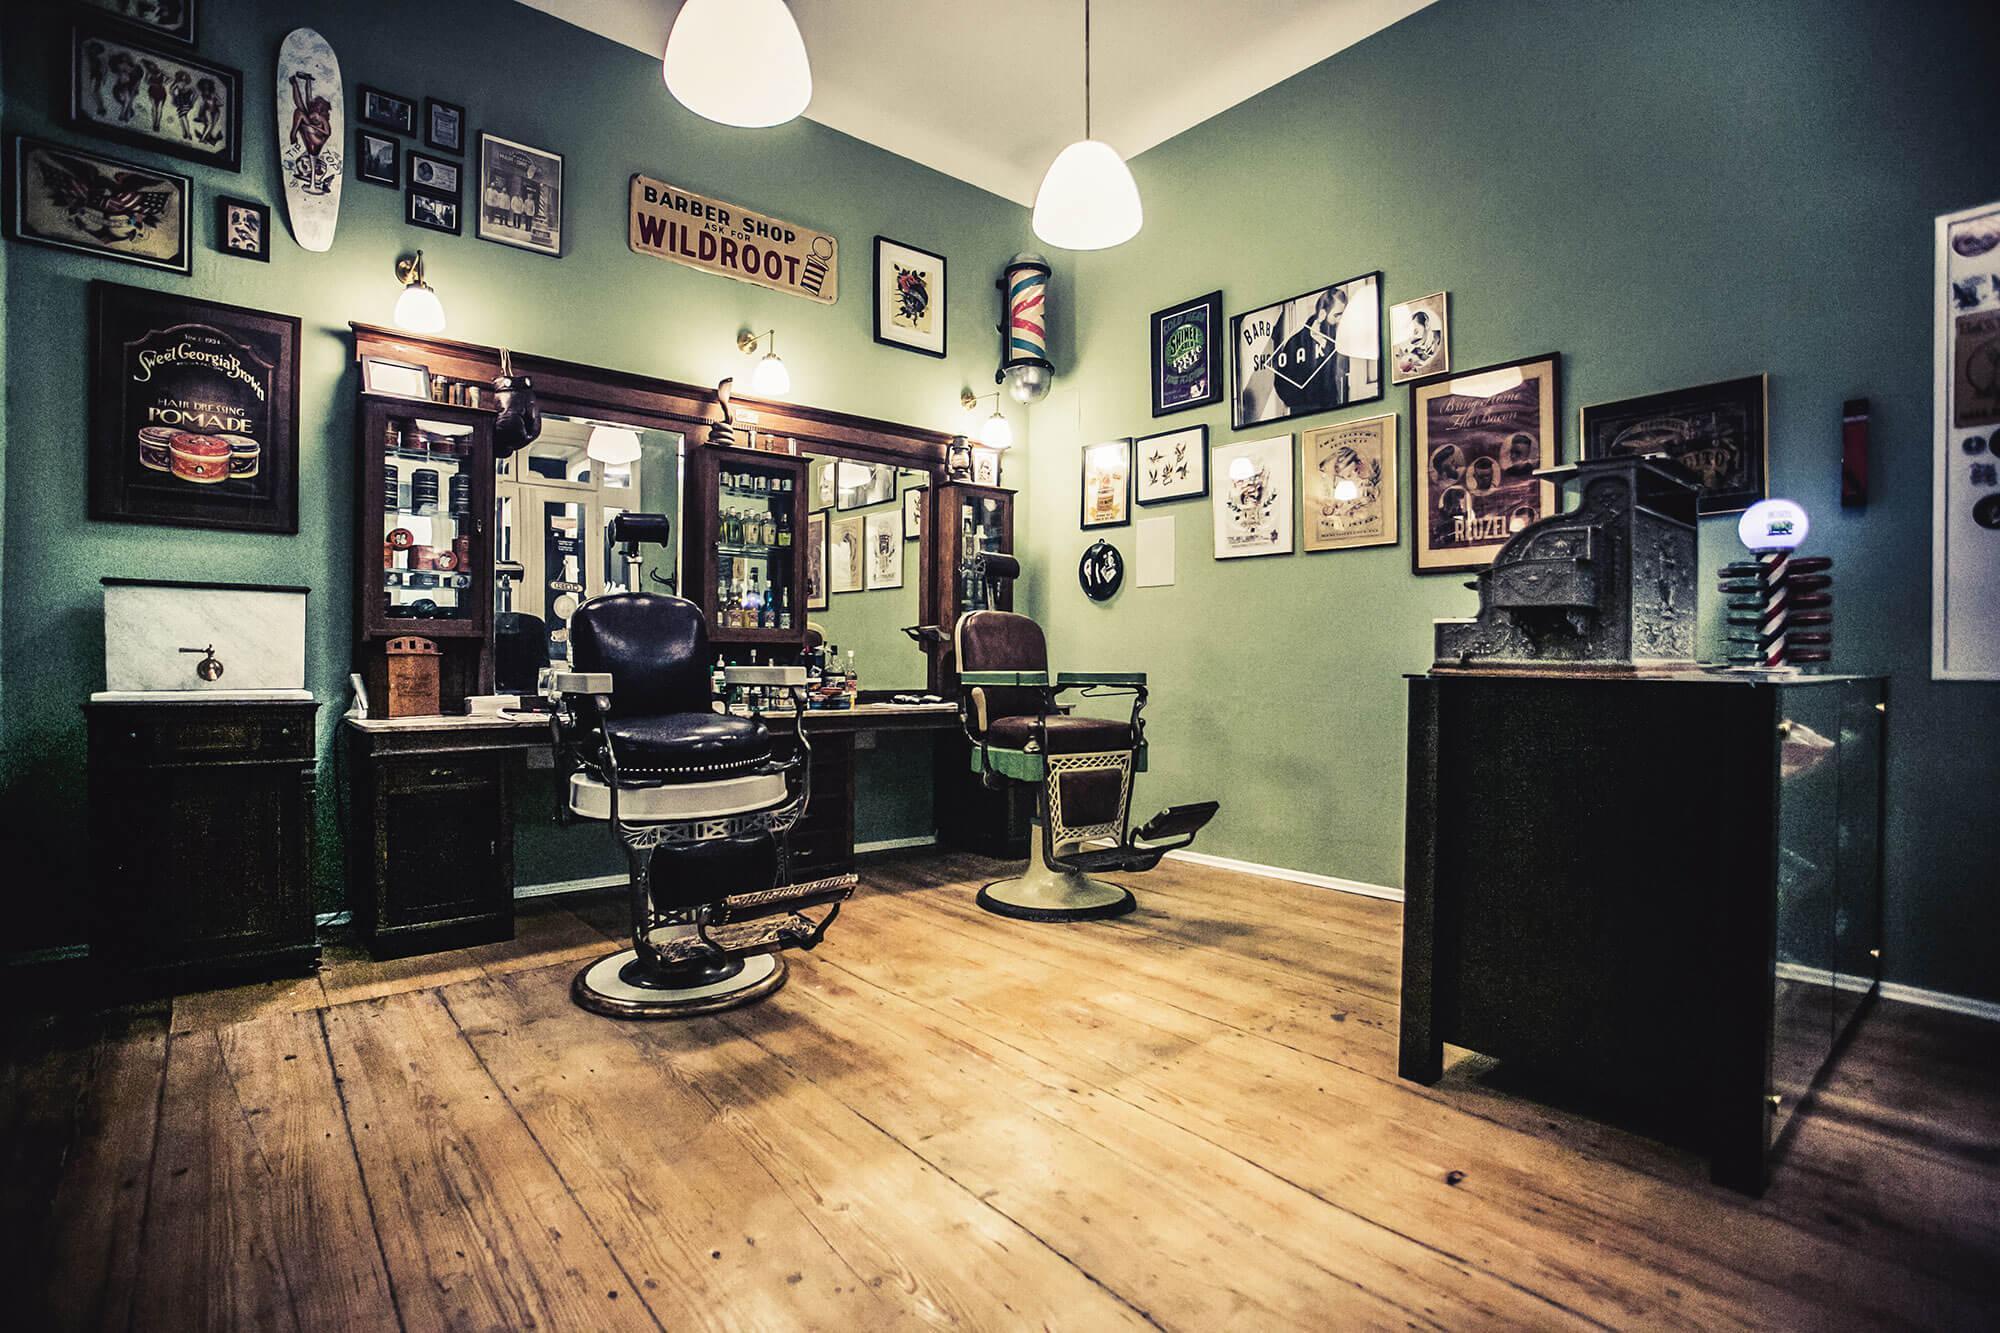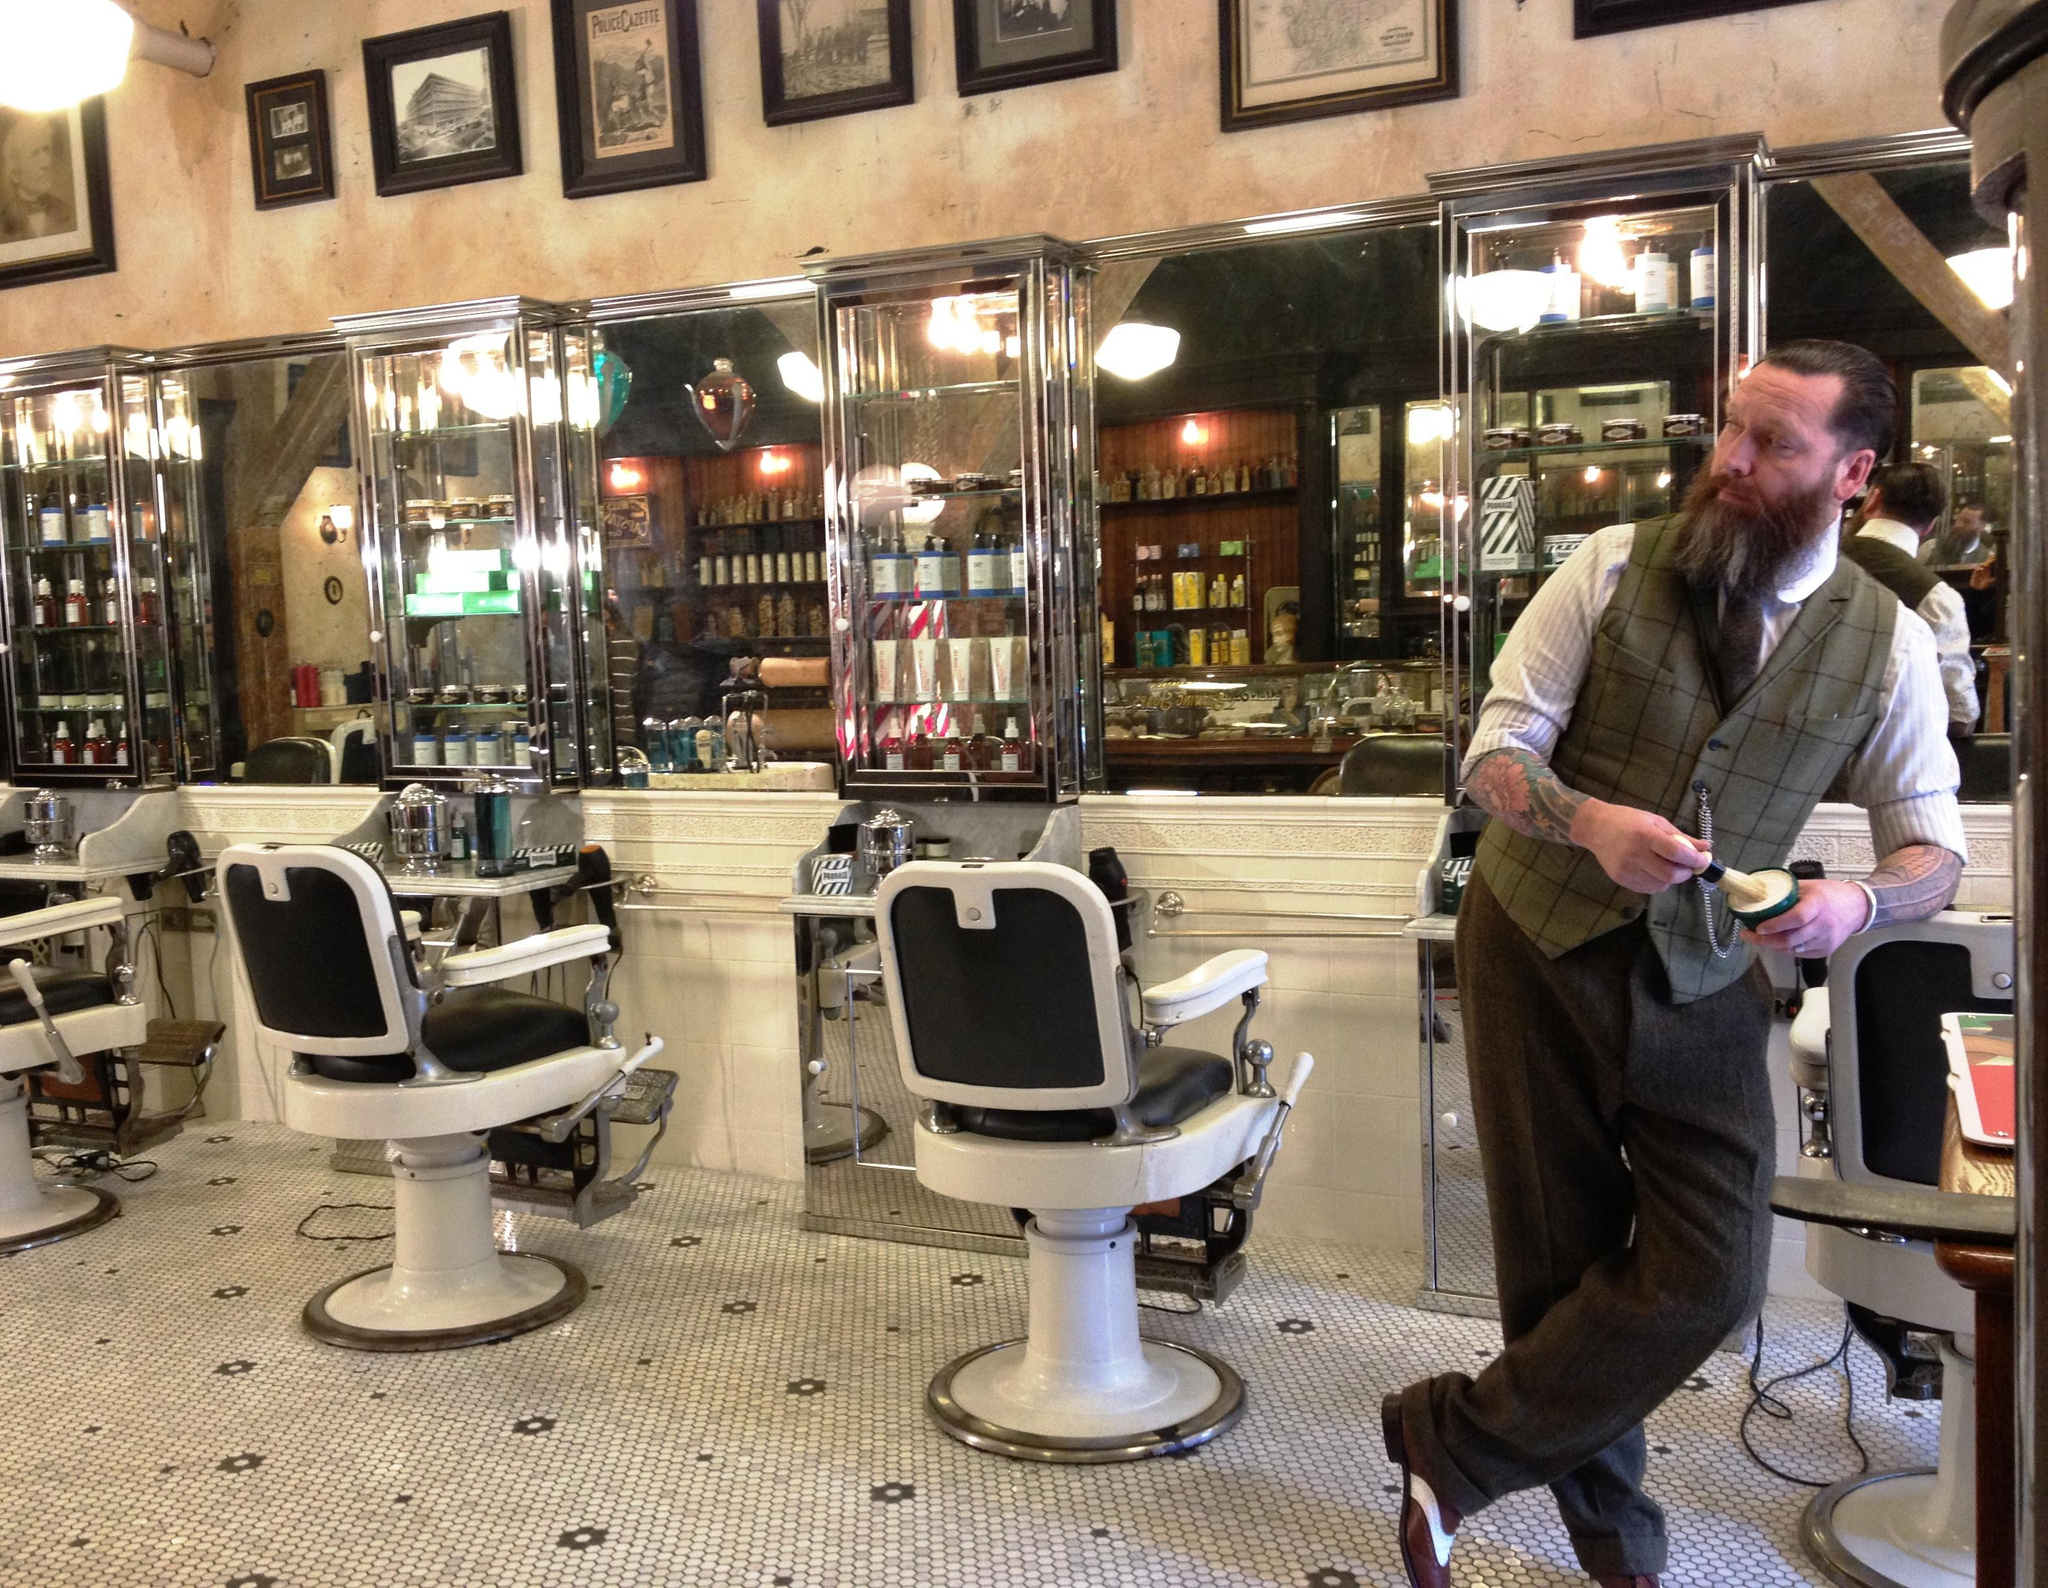The first image is the image on the left, the second image is the image on the right. Considering the images on both sides, is "Barbers are cutting their clients' hair." valid? Answer yes or no. No. The first image is the image on the left, the second image is the image on the right. Evaluate the accuracy of this statement regarding the images: "An image shows barbers working on clients' hair.". Is it true? Answer yes or no. No. 